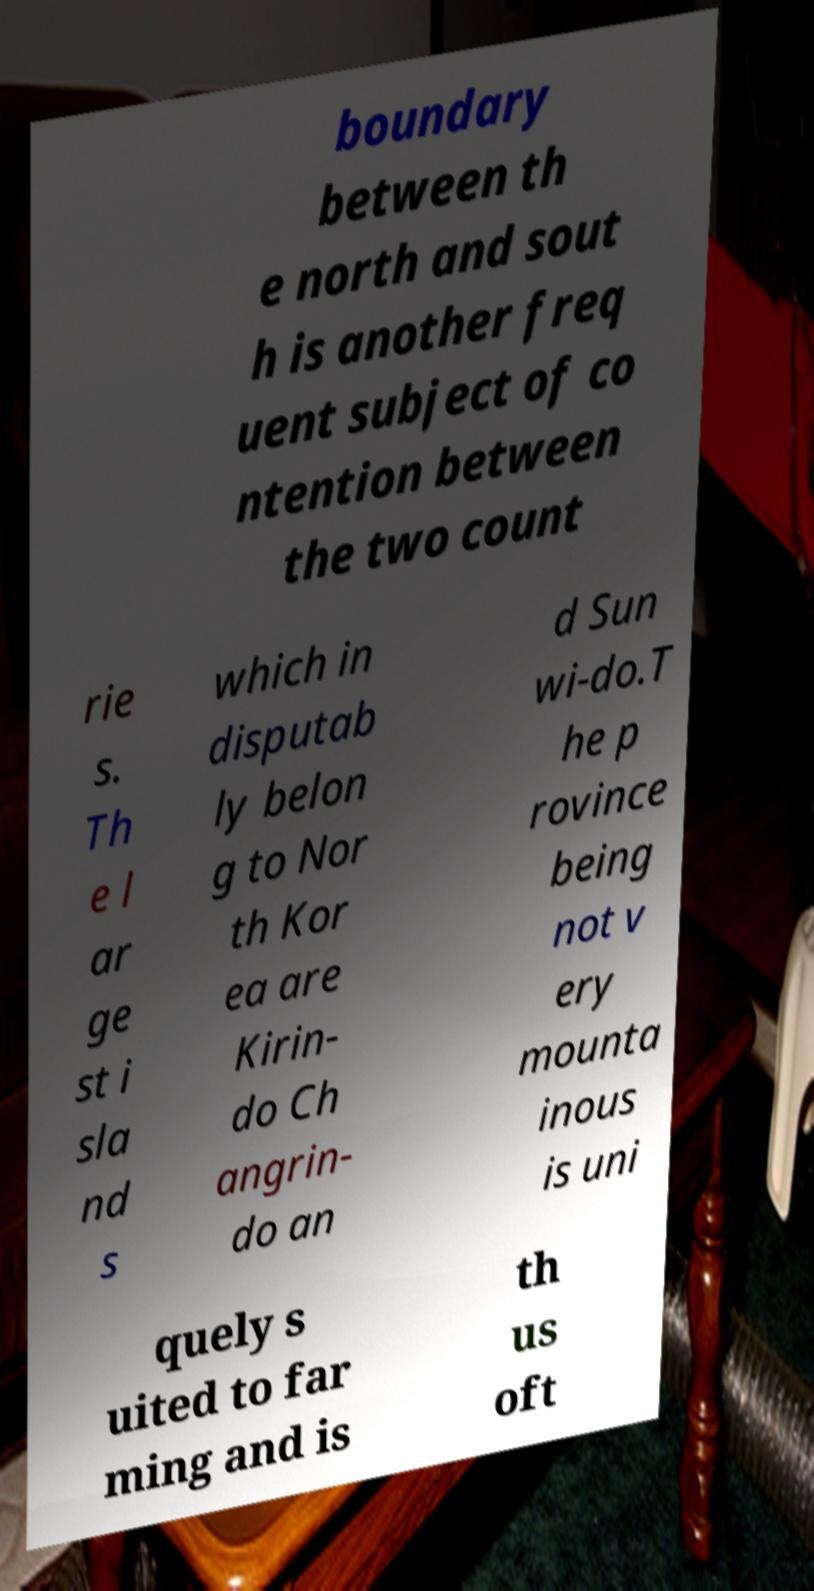Could you extract and type out the text from this image? boundary between th e north and sout h is another freq uent subject of co ntention between the two count rie s. Th e l ar ge st i sla nd s which in disputab ly belon g to Nor th Kor ea are Kirin- do Ch angrin- do an d Sun wi-do.T he p rovince being not v ery mounta inous is uni quely s uited to far ming and is th us oft 